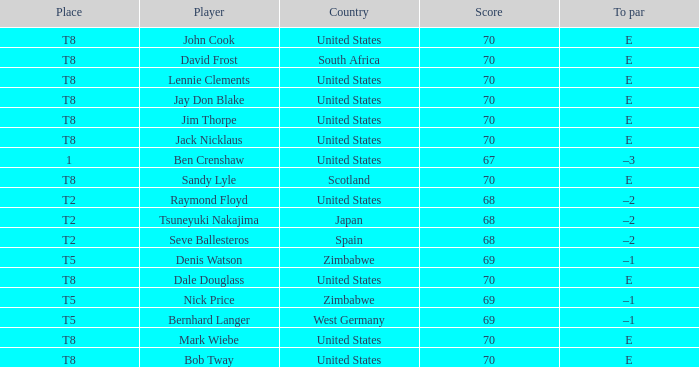What player has The United States as the country with 70 as the score? Jay Don Blake, Lennie Clements, John Cook, Dale Douglass, Jack Nicklaus, Jim Thorpe, Bob Tway, Mark Wiebe. 